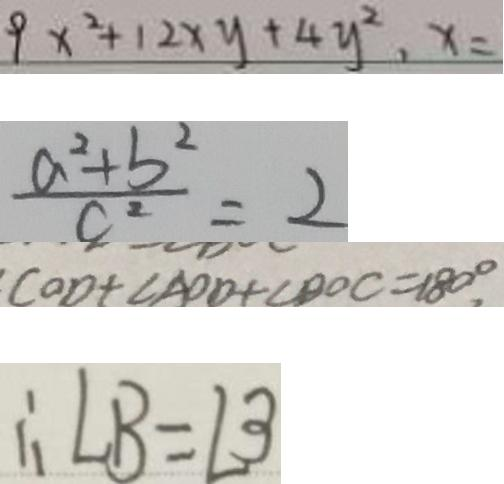Convert formula to latex. <formula><loc_0><loc_0><loc_500><loc_500>9 x ^ { 2 } + 1 2 x y + 4 y ^ { 2 } , x = 
 \frac { a ^ { 2 } + b ^ { 2 } } { c ^ { 2 } } = 2 
 C O D + \angle A O D + \angle D O C = 1 8 0 ^ { \circ } 
 \therefore \angle B = \angle 3</formula> 